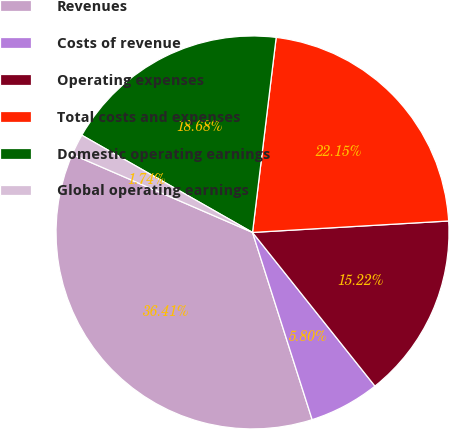Convert chart. <chart><loc_0><loc_0><loc_500><loc_500><pie_chart><fcel>Revenues<fcel>Costs of revenue<fcel>Operating expenses<fcel>Total costs and expenses<fcel>Domestic operating earnings<fcel>Global operating earnings<nl><fcel>36.41%<fcel>5.8%<fcel>15.22%<fcel>22.15%<fcel>18.68%<fcel>1.74%<nl></chart> 